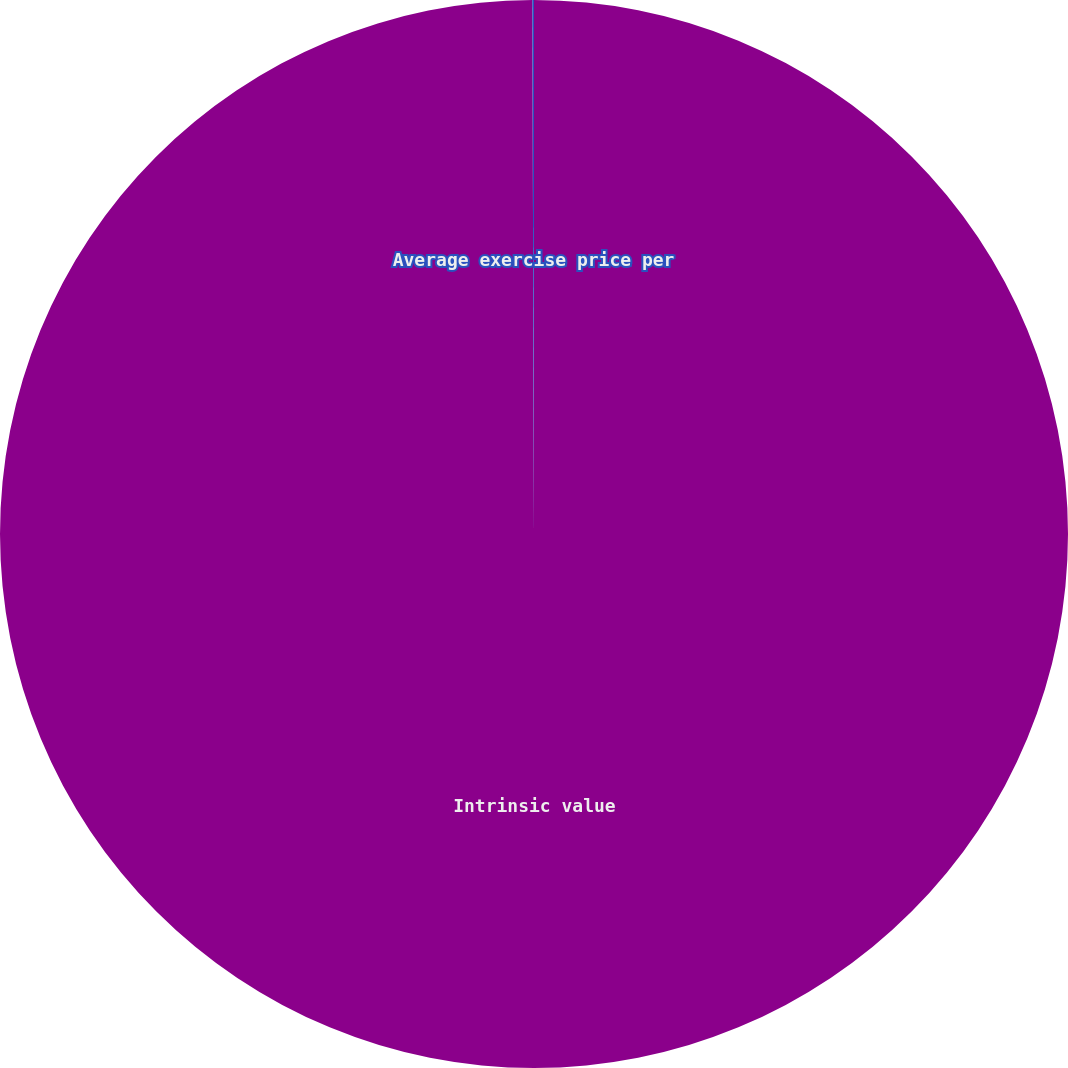Convert chart. <chart><loc_0><loc_0><loc_500><loc_500><pie_chart><fcel>Intrinsic value<fcel>Average exercise price per<nl><fcel>99.95%<fcel>0.05%<nl></chart> 